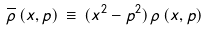Convert formula to latex. <formula><loc_0><loc_0><loc_500><loc_500>\overline { \rho } \, ( x , p ) \, \equiv \, ( x ^ { 2 } - p ^ { 2 } ) \, \rho \, ( x , p ) \,</formula> 